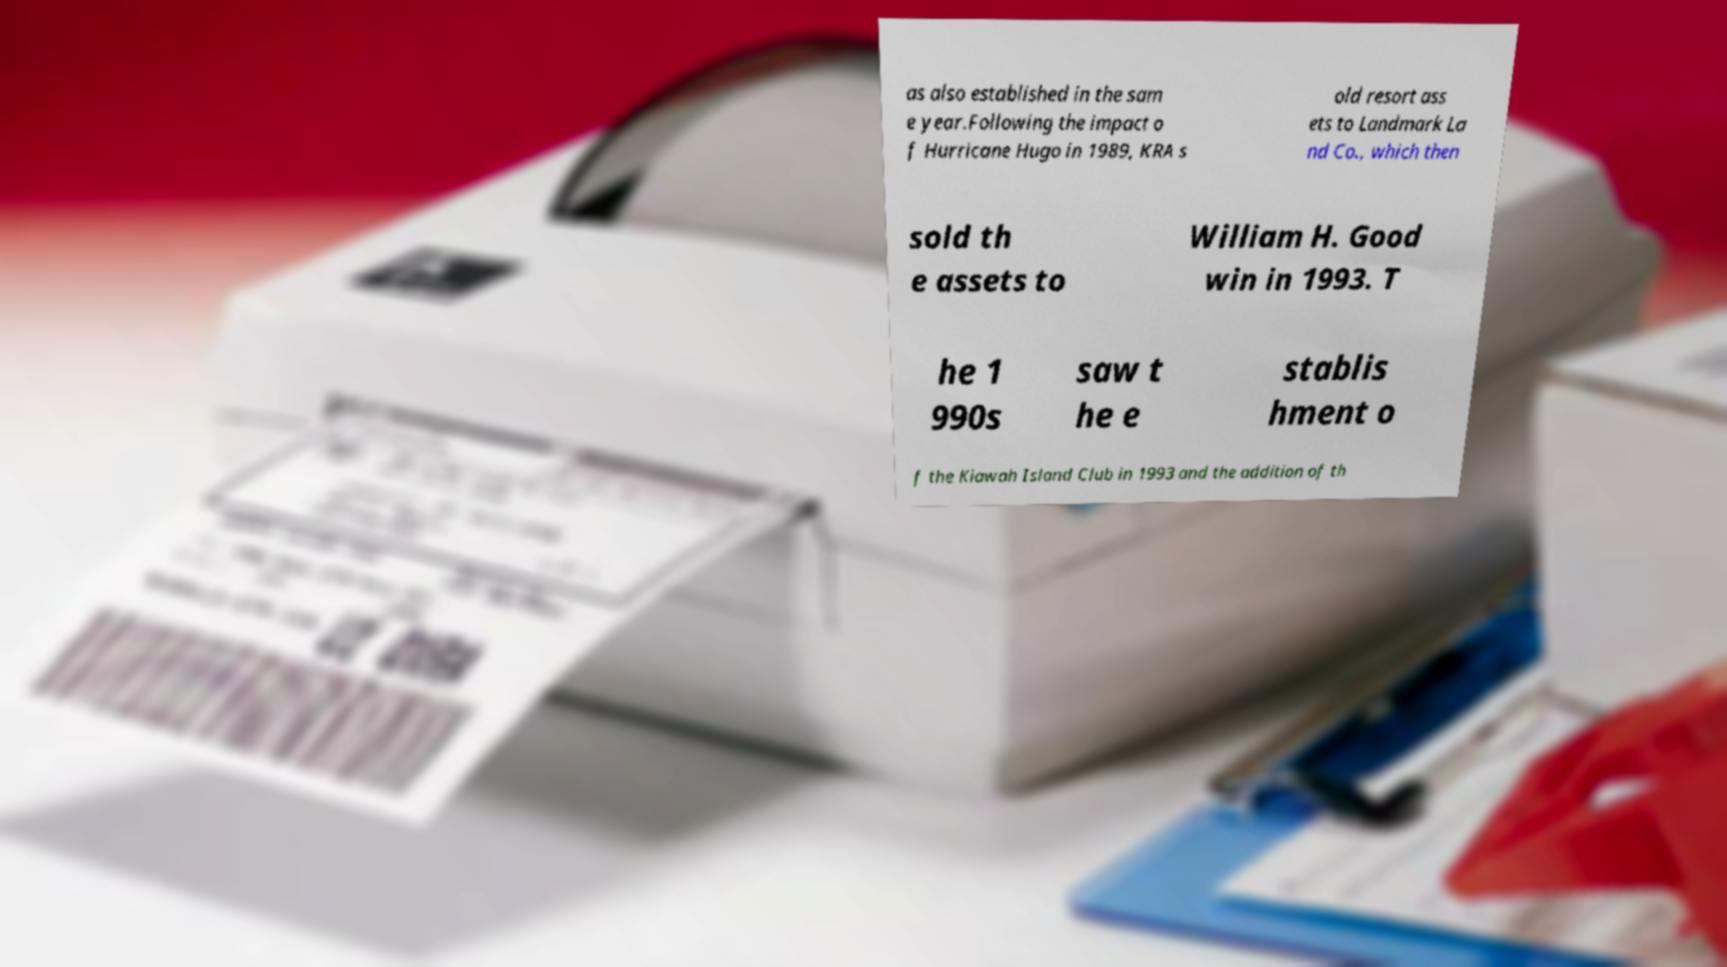For documentation purposes, I need the text within this image transcribed. Could you provide that? as also established in the sam e year.Following the impact o f Hurricane Hugo in 1989, KRA s old resort ass ets to Landmark La nd Co., which then sold th e assets to William H. Good win in 1993. T he 1 990s saw t he e stablis hment o f the Kiawah Island Club in 1993 and the addition of th 